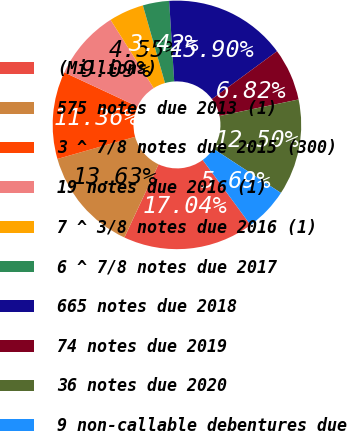Convert chart to OTSL. <chart><loc_0><loc_0><loc_500><loc_500><pie_chart><fcel>(Millions)<fcel>575 notes due 2013 (1)<fcel>3 ^ 7/8 notes due 2015 (300)<fcel>19 notes due 2016 (1)<fcel>7 ^ 3/8 notes due 2016 (1)<fcel>6 ^ 7/8 notes due 2017<fcel>665 notes due 2018<fcel>74 notes due 2019<fcel>36 notes due 2020<fcel>9 non-callable debentures due<nl><fcel>17.04%<fcel>13.63%<fcel>11.36%<fcel>9.09%<fcel>4.55%<fcel>3.42%<fcel>15.9%<fcel>6.82%<fcel>12.5%<fcel>5.69%<nl></chart> 